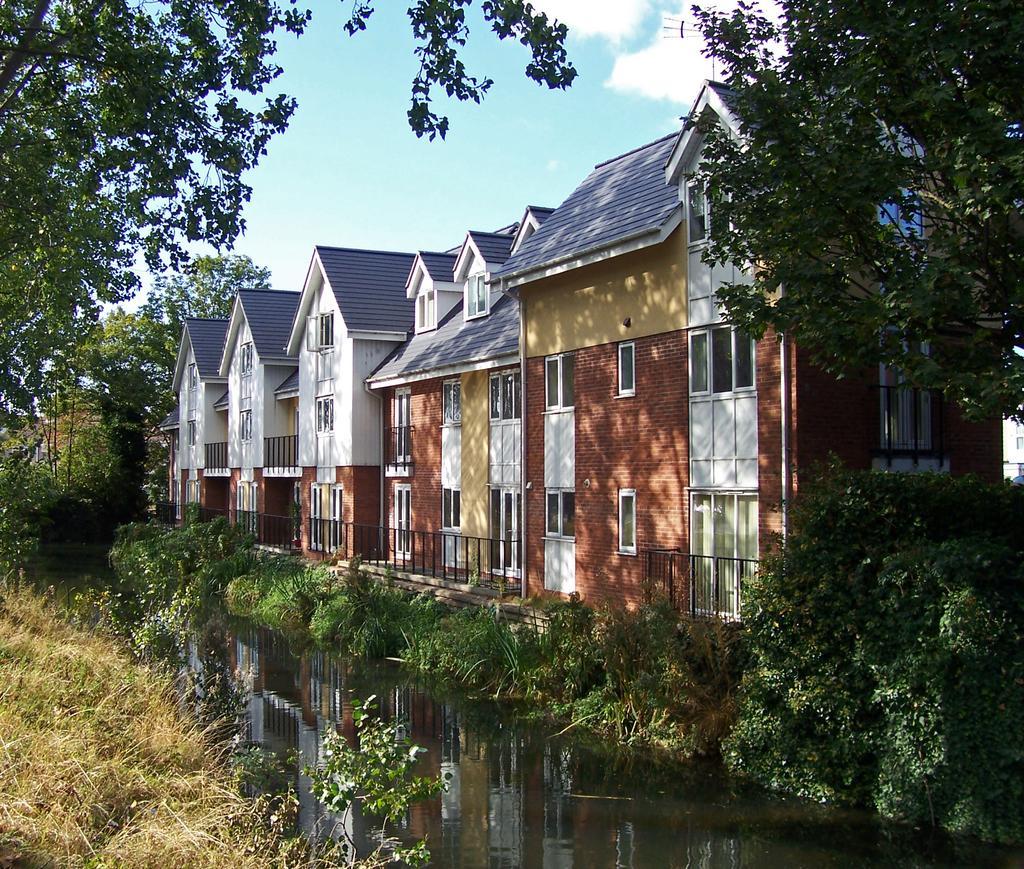Describe this image in one or two sentences. In this picture we can see few plants, water, trees and buildings, in the background we can see clouds. 